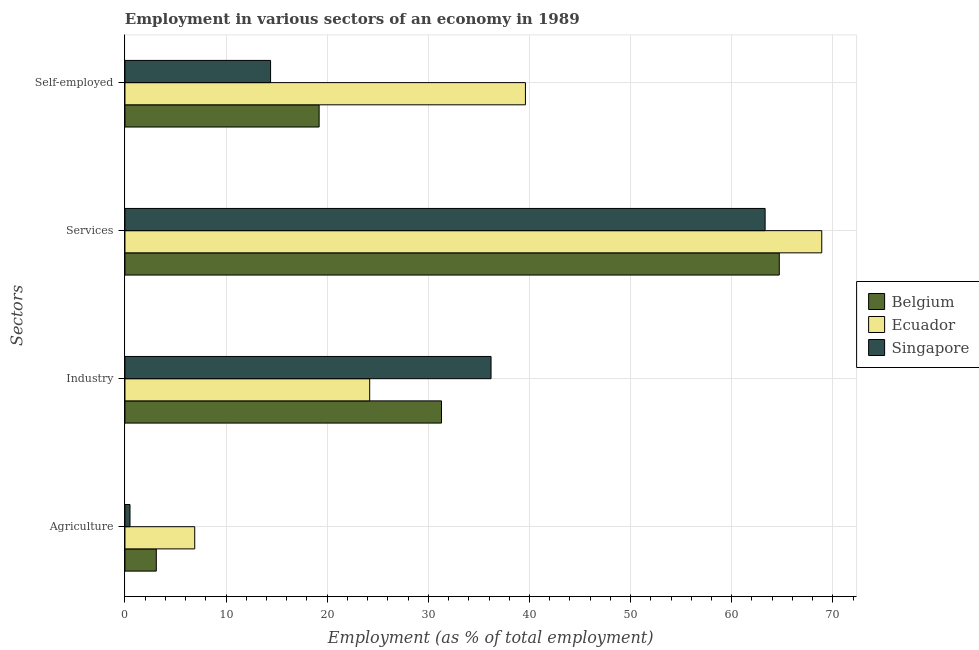How many groups of bars are there?
Offer a terse response. 4. Are the number of bars per tick equal to the number of legend labels?
Keep it short and to the point. Yes. Are the number of bars on each tick of the Y-axis equal?
Keep it short and to the point. Yes. How many bars are there on the 4th tick from the bottom?
Offer a terse response. 3. What is the label of the 2nd group of bars from the top?
Keep it short and to the point. Services. What is the percentage of workers in agriculture in Ecuador?
Your answer should be compact. 6.9. Across all countries, what is the maximum percentage of self employed workers?
Your response must be concise. 39.6. In which country was the percentage of workers in agriculture maximum?
Offer a terse response. Ecuador. In which country was the percentage of self employed workers minimum?
Offer a very short reply. Singapore. What is the total percentage of self employed workers in the graph?
Keep it short and to the point. 73.2. What is the difference between the percentage of self employed workers in Ecuador and that in Belgium?
Keep it short and to the point. 20.4. What is the difference between the percentage of self employed workers in Ecuador and the percentage of workers in services in Belgium?
Your response must be concise. -25.1. What is the average percentage of workers in services per country?
Your answer should be very brief. 65.63. What is the difference between the percentage of self employed workers and percentage of workers in services in Singapore?
Provide a short and direct response. -48.9. In how many countries, is the percentage of self employed workers greater than 58 %?
Your answer should be very brief. 0. What is the ratio of the percentage of workers in services in Ecuador to that in Singapore?
Make the answer very short. 1.09. Is the percentage of self employed workers in Ecuador less than that in Singapore?
Ensure brevity in your answer.  No. What is the difference between the highest and the second highest percentage of workers in services?
Ensure brevity in your answer.  4.2. What is the difference between the highest and the lowest percentage of workers in industry?
Your response must be concise. 12. In how many countries, is the percentage of workers in industry greater than the average percentage of workers in industry taken over all countries?
Make the answer very short. 2. Is the sum of the percentage of workers in industry in Ecuador and Singapore greater than the maximum percentage of self employed workers across all countries?
Your answer should be compact. Yes. What does the 2nd bar from the top in Services represents?
Your response must be concise. Ecuador. What does the 3rd bar from the bottom in Self-employed represents?
Offer a very short reply. Singapore. Is it the case that in every country, the sum of the percentage of workers in agriculture and percentage of workers in industry is greater than the percentage of workers in services?
Give a very brief answer. No. How many bars are there?
Make the answer very short. 12. Are all the bars in the graph horizontal?
Give a very brief answer. Yes. How many countries are there in the graph?
Your answer should be compact. 3. Does the graph contain any zero values?
Your answer should be very brief. No. How many legend labels are there?
Offer a very short reply. 3. How are the legend labels stacked?
Keep it short and to the point. Vertical. What is the title of the graph?
Your response must be concise. Employment in various sectors of an economy in 1989. What is the label or title of the X-axis?
Provide a succinct answer. Employment (as % of total employment). What is the label or title of the Y-axis?
Give a very brief answer. Sectors. What is the Employment (as % of total employment) in Belgium in Agriculture?
Keep it short and to the point. 3.1. What is the Employment (as % of total employment) in Ecuador in Agriculture?
Ensure brevity in your answer.  6.9. What is the Employment (as % of total employment) in Singapore in Agriculture?
Give a very brief answer. 0.5. What is the Employment (as % of total employment) in Belgium in Industry?
Your response must be concise. 31.3. What is the Employment (as % of total employment) in Ecuador in Industry?
Your answer should be very brief. 24.2. What is the Employment (as % of total employment) in Singapore in Industry?
Give a very brief answer. 36.2. What is the Employment (as % of total employment) of Belgium in Services?
Your answer should be compact. 64.7. What is the Employment (as % of total employment) of Ecuador in Services?
Your answer should be very brief. 68.9. What is the Employment (as % of total employment) of Singapore in Services?
Keep it short and to the point. 63.3. What is the Employment (as % of total employment) of Belgium in Self-employed?
Make the answer very short. 19.2. What is the Employment (as % of total employment) of Ecuador in Self-employed?
Your response must be concise. 39.6. What is the Employment (as % of total employment) of Singapore in Self-employed?
Provide a succinct answer. 14.4. Across all Sectors, what is the maximum Employment (as % of total employment) in Belgium?
Offer a very short reply. 64.7. Across all Sectors, what is the maximum Employment (as % of total employment) of Ecuador?
Your answer should be very brief. 68.9. Across all Sectors, what is the maximum Employment (as % of total employment) in Singapore?
Keep it short and to the point. 63.3. Across all Sectors, what is the minimum Employment (as % of total employment) in Belgium?
Offer a very short reply. 3.1. Across all Sectors, what is the minimum Employment (as % of total employment) of Ecuador?
Make the answer very short. 6.9. Across all Sectors, what is the minimum Employment (as % of total employment) in Singapore?
Keep it short and to the point. 0.5. What is the total Employment (as % of total employment) of Belgium in the graph?
Provide a short and direct response. 118.3. What is the total Employment (as % of total employment) in Ecuador in the graph?
Give a very brief answer. 139.6. What is the total Employment (as % of total employment) in Singapore in the graph?
Keep it short and to the point. 114.4. What is the difference between the Employment (as % of total employment) of Belgium in Agriculture and that in Industry?
Offer a terse response. -28.2. What is the difference between the Employment (as % of total employment) of Ecuador in Agriculture and that in Industry?
Offer a very short reply. -17.3. What is the difference between the Employment (as % of total employment) in Singapore in Agriculture and that in Industry?
Your answer should be very brief. -35.7. What is the difference between the Employment (as % of total employment) in Belgium in Agriculture and that in Services?
Provide a succinct answer. -61.6. What is the difference between the Employment (as % of total employment) in Ecuador in Agriculture and that in Services?
Give a very brief answer. -62. What is the difference between the Employment (as % of total employment) of Singapore in Agriculture and that in Services?
Provide a succinct answer. -62.8. What is the difference between the Employment (as % of total employment) in Belgium in Agriculture and that in Self-employed?
Ensure brevity in your answer.  -16.1. What is the difference between the Employment (as % of total employment) in Ecuador in Agriculture and that in Self-employed?
Make the answer very short. -32.7. What is the difference between the Employment (as % of total employment) of Singapore in Agriculture and that in Self-employed?
Provide a succinct answer. -13.9. What is the difference between the Employment (as % of total employment) in Belgium in Industry and that in Services?
Offer a very short reply. -33.4. What is the difference between the Employment (as % of total employment) in Ecuador in Industry and that in Services?
Provide a succinct answer. -44.7. What is the difference between the Employment (as % of total employment) of Singapore in Industry and that in Services?
Offer a very short reply. -27.1. What is the difference between the Employment (as % of total employment) in Belgium in Industry and that in Self-employed?
Your response must be concise. 12.1. What is the difference between the Employment (as % of total employment) in Ecuador in Industry and that in Self-employed?
Give a very brief answer. -15.4. What is the difference between the Employment (as % of total employment) in Singapore in Industry and that in Self-employed?
Provide a short and direct response. 21.8. What is the difference between the Employment (as % of total employment) in Belgium in Services and that in Self-employed?
Your response must be concise. 45.5. What is the difference between the Employment (as % of total employment) in Ecuador in Services and that in Self-employed?
Give a very brief answer. 29.3. What is the difference between the Employment (as % of total employment) in Singapore in Services and that in Self-employed?
Provide a succinct answer. 48.9. What is the difference between the Employment (as % of total employment) in Belgium in Agriculture and the Employment (as % of total employment) in Ecuador in Industry?
Offer a terse response. -21.1. What is the difference between the Employment (as % of total employment) of Belgium in Agriculture and the Employment (as % of total employment) of Singapore in Industry?
Keep it short and to the point. -33.1. What is the difference between the Employment (as % of total employment) in Ecuador in Agriculture and the Employment (as % of total employment) in Singapore in Industry?
Provide a succinct answer. -29.3. What is the difference between the Employment (as % of total employment) of Belgium in Agriculture and the Employment (as % of total employment) of Ecuador in Services?
Provide a succinct answer. -65.8. What is the difference between the Employment (as % of total employment) of Belgium in Agriculture and the Employment (as % of total employment) of Singapore in Services?
Your response must be concise. -60.2. What is the difference between the Employment (as % of total employment) of Ecuador in Agriculture and the Employment (as % of total employment) of Singapore in Services?
Provide a short and direct response. -56.4. What is the difference between the Employment (as % of total employment) of Belgium in Agriculture and the Employment (as % of total employment) of Ecuador in Self-employed?
Give a very brief answer. -36.5. What is the difference between the Employment (as % of total employment) in Belgium in Industry and the Employment (as % of total employment) in Ecuador in Services?
Keep it short and to the point. -37.6. What is the difference between the Employment (as % of total employment) of Belgium in Industry and the Employment (as % of total employment) of Singapore in Services?
Your answer should be very brief. -32. What is the difference between the Employment (as % of total employment) in Ecuador in Industry and the Employment (as % of total employment) in Singapore in Services?
Your answer should be very brief. -39.1. What is the difference between the Employment (as % of total employment) in Belgium in Industry and the Employment (as % of total employment) in Ecuador in Self-employed?
Ensure brevity in your answer.  -8.3. What is the difference between the Employment (as % of total employment) of Ecuador in Industry and the Employment (as % of total employment) of Singapore in Self-employed?
Keep it short and to the point. 9.8. What is the difference between the Employment (as % of total employment) in Belgium in Services and the Employment (as % of total employment) in Ecuador in Self-employed?
Your answer should be compact. 25.1. What is the difference between the Employment (as % of total employment) of Belgium in Services and the Employment (as % of total employment) of Singapore in Self-employed?
Provide a short and direct response. 50.3. What is the difference between the Employment (as % of total employment) of Ecuador in Services and the Employment (as % of total employment) of Singapore in Self-employed?
Make the answer very short. 54.5. What is the average Employment (as % of total employment) of Belgium per Sectors?
Your answer should be very brief. 29.57. What is the average Employment (as % of total employment) in Ecuador per Sectors?
Your answer should be compact. 34.9. What is the average Employment (as % of total employment) of Singapore per Sectors?
Offer a terse response. 28.6. What is the difference between the Employment (as % of total employment) in Belgium and Employment (as % of total employment) in Singapore in Agriculture?
Your answer should be very brief. 2.6. What is the difference between the Employment (as % of total employment) in Ecuador and Employment (as % of total employment) in Singapore in Agriculture?
Keep it short and to the point. 6.4. What is the difference between the Employment (as % of total employment) of Belgium and Employment (as % of total employment) of Ecuador in Industry?
Provide a short and direct response. 7.1. What is the difference between the Employment (as % of total employment) in Ecuador and Employment (as % of total employment) in Singapore in Industry?
Offer a terse response. -12. What is the difference between the Employment (as % of total employment) of Ecuador and Employment (as % of total employment) of Singapore in Services?
Your answer should be compact. 5.6. What is the difference between the Employment (as % of total employment) in Belgium and Employment (as % of total employment) in Ecuador in Self-employed?
Provide a succinct answer. -20.4. What is the difference between the Employment (as % of total employment) in Ecuador and Employment (as % of total employment) in Singapore in Self-employed?
Provide a succinct answer. 25.2. What is the ratio of the Employment (as % of total employment) of Belgium in Agriculture to that in Industry?
Your answer should be very brief. 0.1. What is the ratio of the Employment (as % of total employment) of Ecuador in Agriculture to that in Industry?
Make the answer very short. 0.29. What is the ratio of the Employment (as % of total employment) of Singapore in Agriculture to that in Industry?
Offer a terse response. 0.01. What is the ratio of the Employment (as % of total employment) of Belgium in Agriculture to that in Services?
Your response must be concise. 0.05. What is the ratio of the Employment (as % of total employment) in Ecuador in Agriculture to that in Services?
Provide a short and direct response. 0.1. What is the ratio of the Employment (as % of total employment) in Singapore in Agriculture to that in Services?
Provide a short and direct response. 0.01. What is the ratio of the Employment (as % of total employment) in Belgium in Agriculture to that in Self-employed?
Keep it short and to the point. 0.16. What is the ratio of the Employment (as % of total employment) in Ecuador in Agriculture to that in Self-employed?
Ensure brevity in your answer.  0.17. What is the ratio of the Employment (as % of total employment) of Singapore in Agriculture to that in Self-employed?
Provide a short and direct response. 0.03. What is the ratio of the Employment (as % of total employment) of Belgium in Industry to that in Services?
Provide a succinct answer. 0.48. What is the ratio of the Employment (as % of total employment) of Ecuador in Industry to that in Services?
Offer a very short reply. 0.35. What is the ratio of the Employment (as % of total employment) in Singapore in Industry to that in Services?
Provide a short and direct response. 0.57. What is the ratio of the Employment (as % of total employment) in Belgium in Industry to that in Self-employed?
Give a very brief answer. 1.63. What is the ratio of the Employment (as % of total employment) of Ecuador in Industry to that in Self-employed?
Your answer should be compact. 0.61. What is the ratio of the Employment (as % of total employment) in Singapore in Industry to that in Self-employed?
Offer a very short reply. 2.51. What is the ratio of the Employment (as % of total employment) of Belgium in Services to that in Self-employed?
Offer a terse response. 3.37. What is the ratio of the Employment (as % of total employment) in Ecuador in Services to that in Self-employed?
Provide a succinct answer. 1.74. What is the ratio of the Employment (as % of total employment) of Singapore in Services to that in Self-employed?
Your answer should be very brief. 4.4. What is the difference between the highest and the second highest Employment (as % of total employment) in Belgium?
Provide a short and direct response. 33.4. What is the difference between the highest and the second highest Employment (as % of total employment) of Ecuador?
Your answer should be very brief. 29.3. What is the difference between the highest and the second highest Employment (as % of total employment) of Singapore?
Provide a short and direct response. 27.1. What is the difference between the highest and the lowest Employment (as % of total employment) in Belgium?
Provide a short and direct response. 61.6. What is the difference between the highest and the lowest Employment (as % of total employment) of Ecuador?
Give a very brief answer. 62. What is the difference between the highest and the lowest Employment (as % of total employment) in Singapore?
Provide a succinct answer. 62.8. 